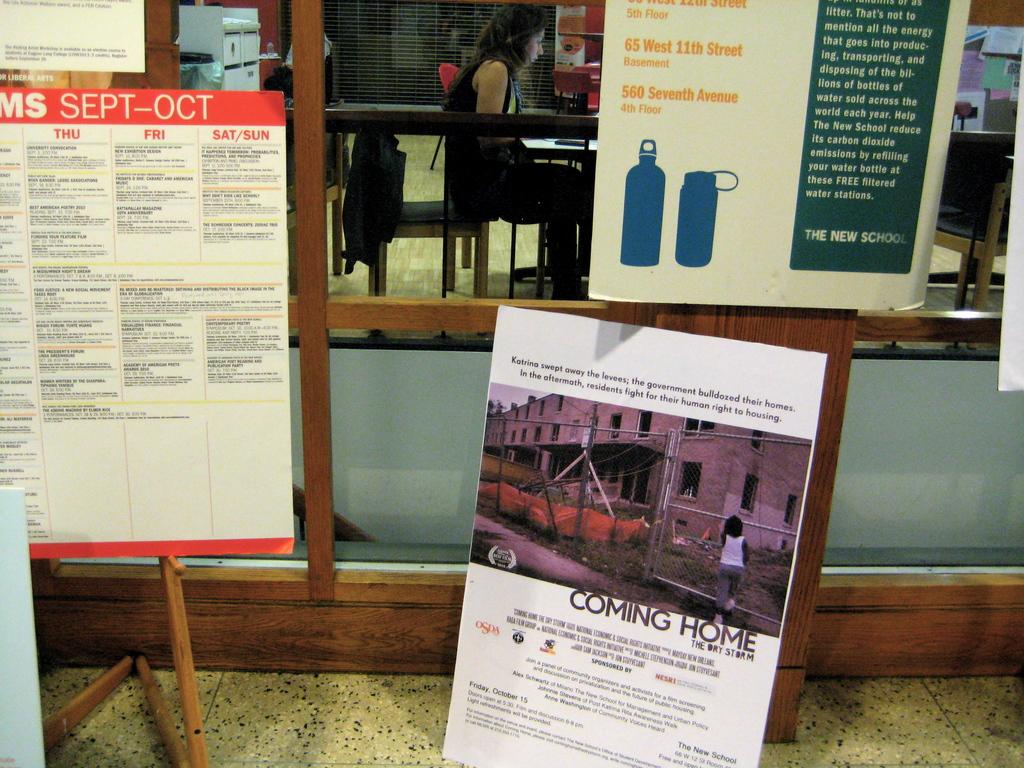When is the event?
Give a very brief answer. Sept-oct. 